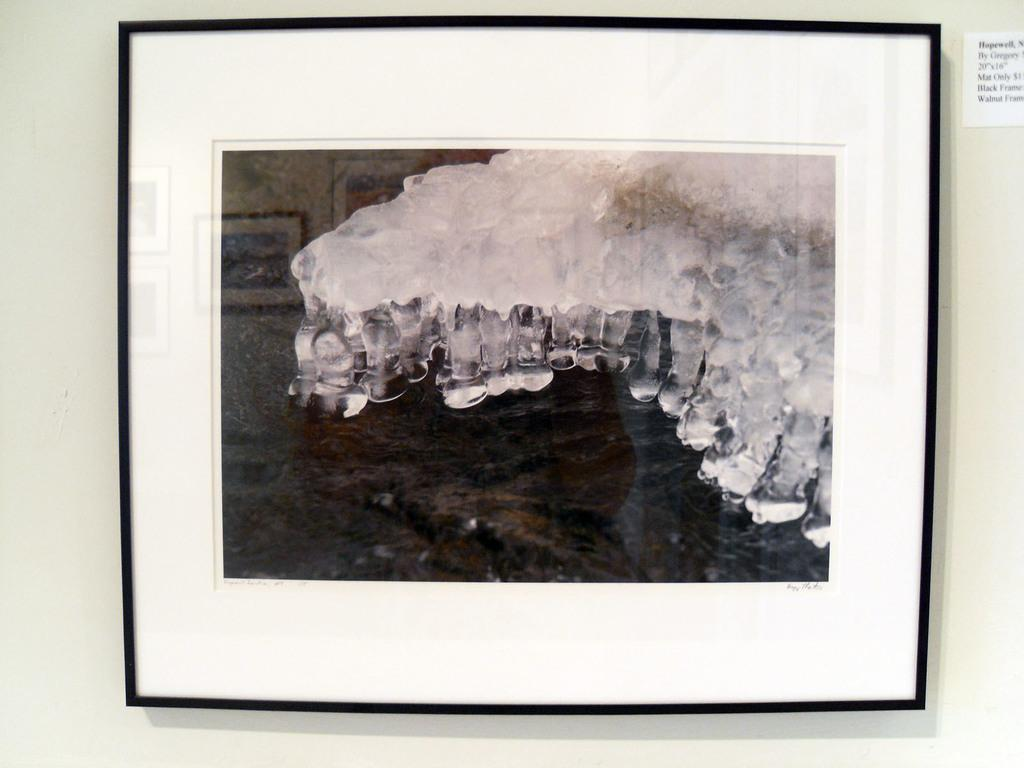What is the main subject of the image? The image contains a frame. What is depicted inside the frame? There is a picture of a jellyfish in the frame. Where is the frame located in the image? The frame is on a wall. Are there any additional decorations or items on the wall? Yes, there is a sticker on the wall. How does the jellyfish fall from the frame in the image? The jellyfish does not fall from the frame in the image; it is a picture of a jellyfish inside the frame. 